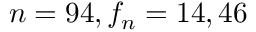<formula> <loc_0><loc_0><loc_500><loc_500>n = 9 4 , f _ { n } = 1 4 , 4 6</formula> 